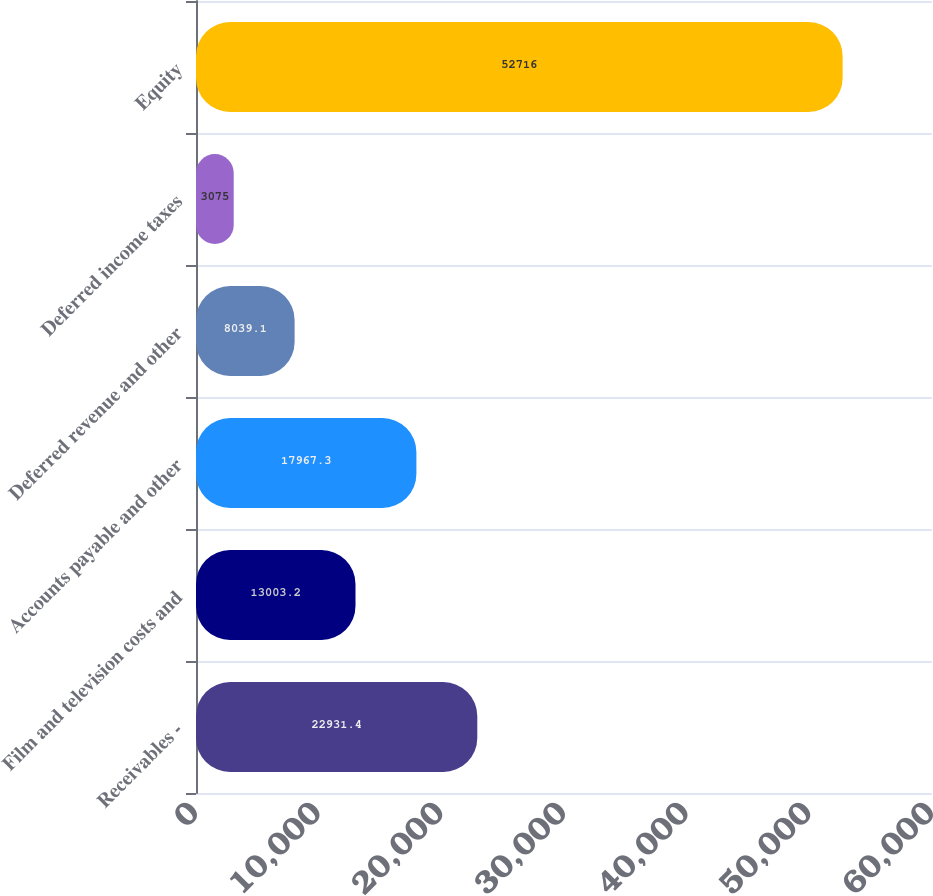Convert chart. <chart><loc_0><loc_0><loc_500><loc_500><bar_chart><fcel>Receivables -<fcel>Film and television costs and<fcel>Accounts payable and other<fcel>Deferred revenue and other<fcel>Deferred income taxes<fcel>Equity<nl><fcel>22931.4<fcel>13003.2<fcel>17967.3<fcel>8039.1<fcel>3075<fcel>52716<nl></chart> 